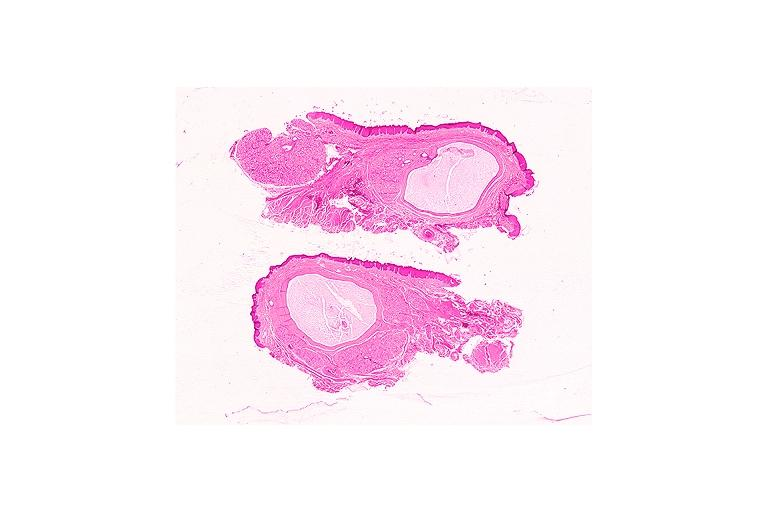what is present?
Answer the question using a single word or phrase. Oral 